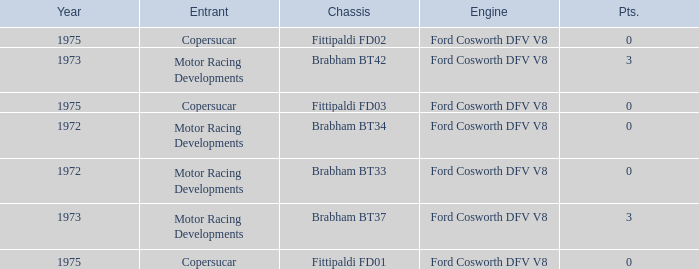Which engine from 1973 has a Brabham bt37 chassis? Ford Cosworth DFV V8. 